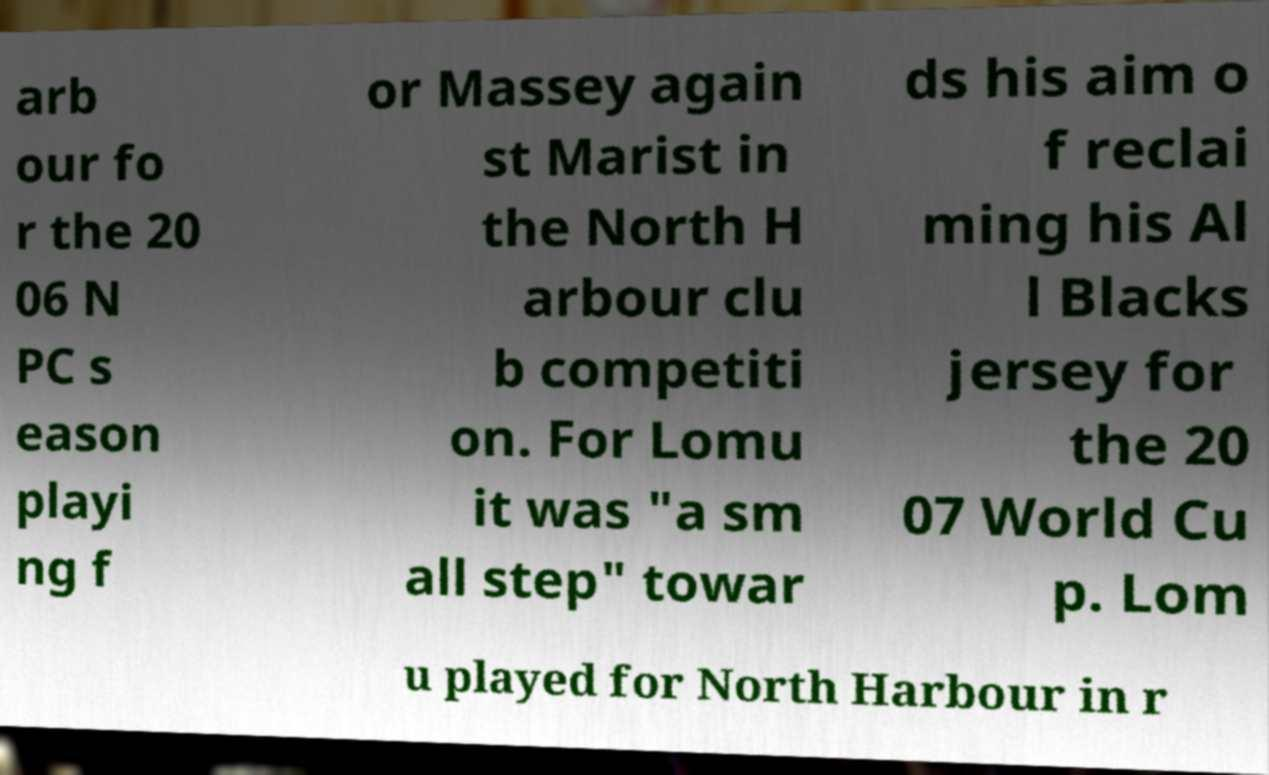For documentation purposes, I need the text within this image transcribed. Could you provide that? arb our fo r the 20 06 N PC s eason playi ng f or Massey again st Marist in the North H arbour clu b competiti on. For Lomu it was "a sm all step" towar ds his aim o f reclai ming his Al l Blacks jersey for the 20 07 World Cu p. Lom u played for North Harbour in r 